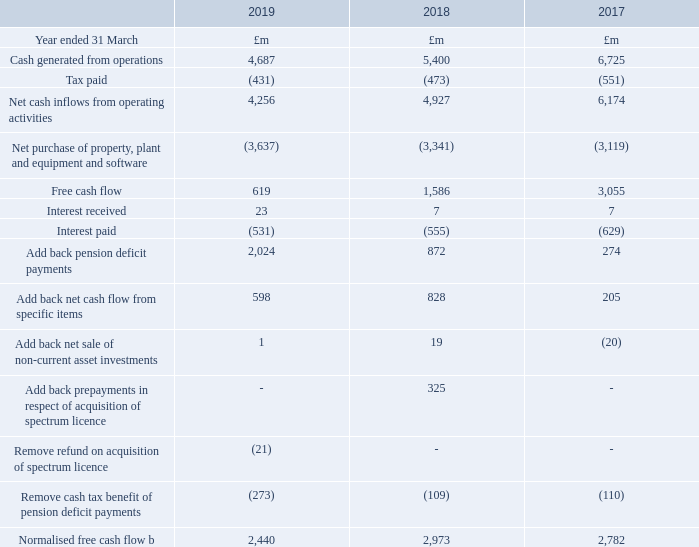Summarised cash flow statement
Cash flow
We generated a net cash inflow from operating activities of £4,256m, down £671m, mainly driven by £2bn contributions to the BT Pension Scheme, offset by favourable working capital movements. In line with our outlook, normalised free cash flowb was £2,440m, down £533m or 18%, driven by increased cash capital expenditure, decrease in EBITDA and higher tax payments.
Free cash flow, which includes specific item outflows of £598m (2017/18: £828m) and a £273m (2017/18: £109m) tax benefit from pension deficit payments, was £619m (2017/18: £1,586m). Last year also included payments of £325m for the acquisition of mobile spectrum.
The spectrum auction bidding took place across the 2017/18 and 2018/19 financial years. Whilst £325m was on deposit with Ofcom at 31 March 2018, we went on to acquire spectrum for a total price of £304m and the excess deposit balance has since been refunded. We made pension deficit payments of £2,024m (2017/18: £872m) and paid dividends to our shareholders of £1,504m (2017/18: £1,523m).
The net cash cost of specific items of £598m (2017/18: £828m) includes restructuring payments of £372m (2017/18: £189m) and regulatory payments of £170m (2017/18: £267m). Last year also included payments of £225m relating to the settlement of warranty claims under the 2015 EE acquisition agreement.
b After net interest paid, before pension deficit payments (including the cash tax benefit of pension deficit payments) and specific items.
What was the net cash inflow from operating activities? £4,256m. What was the tax benefit from pension deficit payments included in Free Cash Flow? £273m. What are the years that cash flow details were reported in the table? 2017, 2018, 2019. What was the change in Cash generated from operations from 2018 to 2019?
Answer scale should be: million. 4,687 - 5,400
Answer: -713. What is the average tax paid for 2017-2019?
Answer scale should be: million. -(431 + 473 + 551) / 3
Answer: -485. What is the change in the Net cash inflows from operating activities from 2018 to 2019?
Answer scale should be: million. 4,256 - 4,927
Answer: -671. 